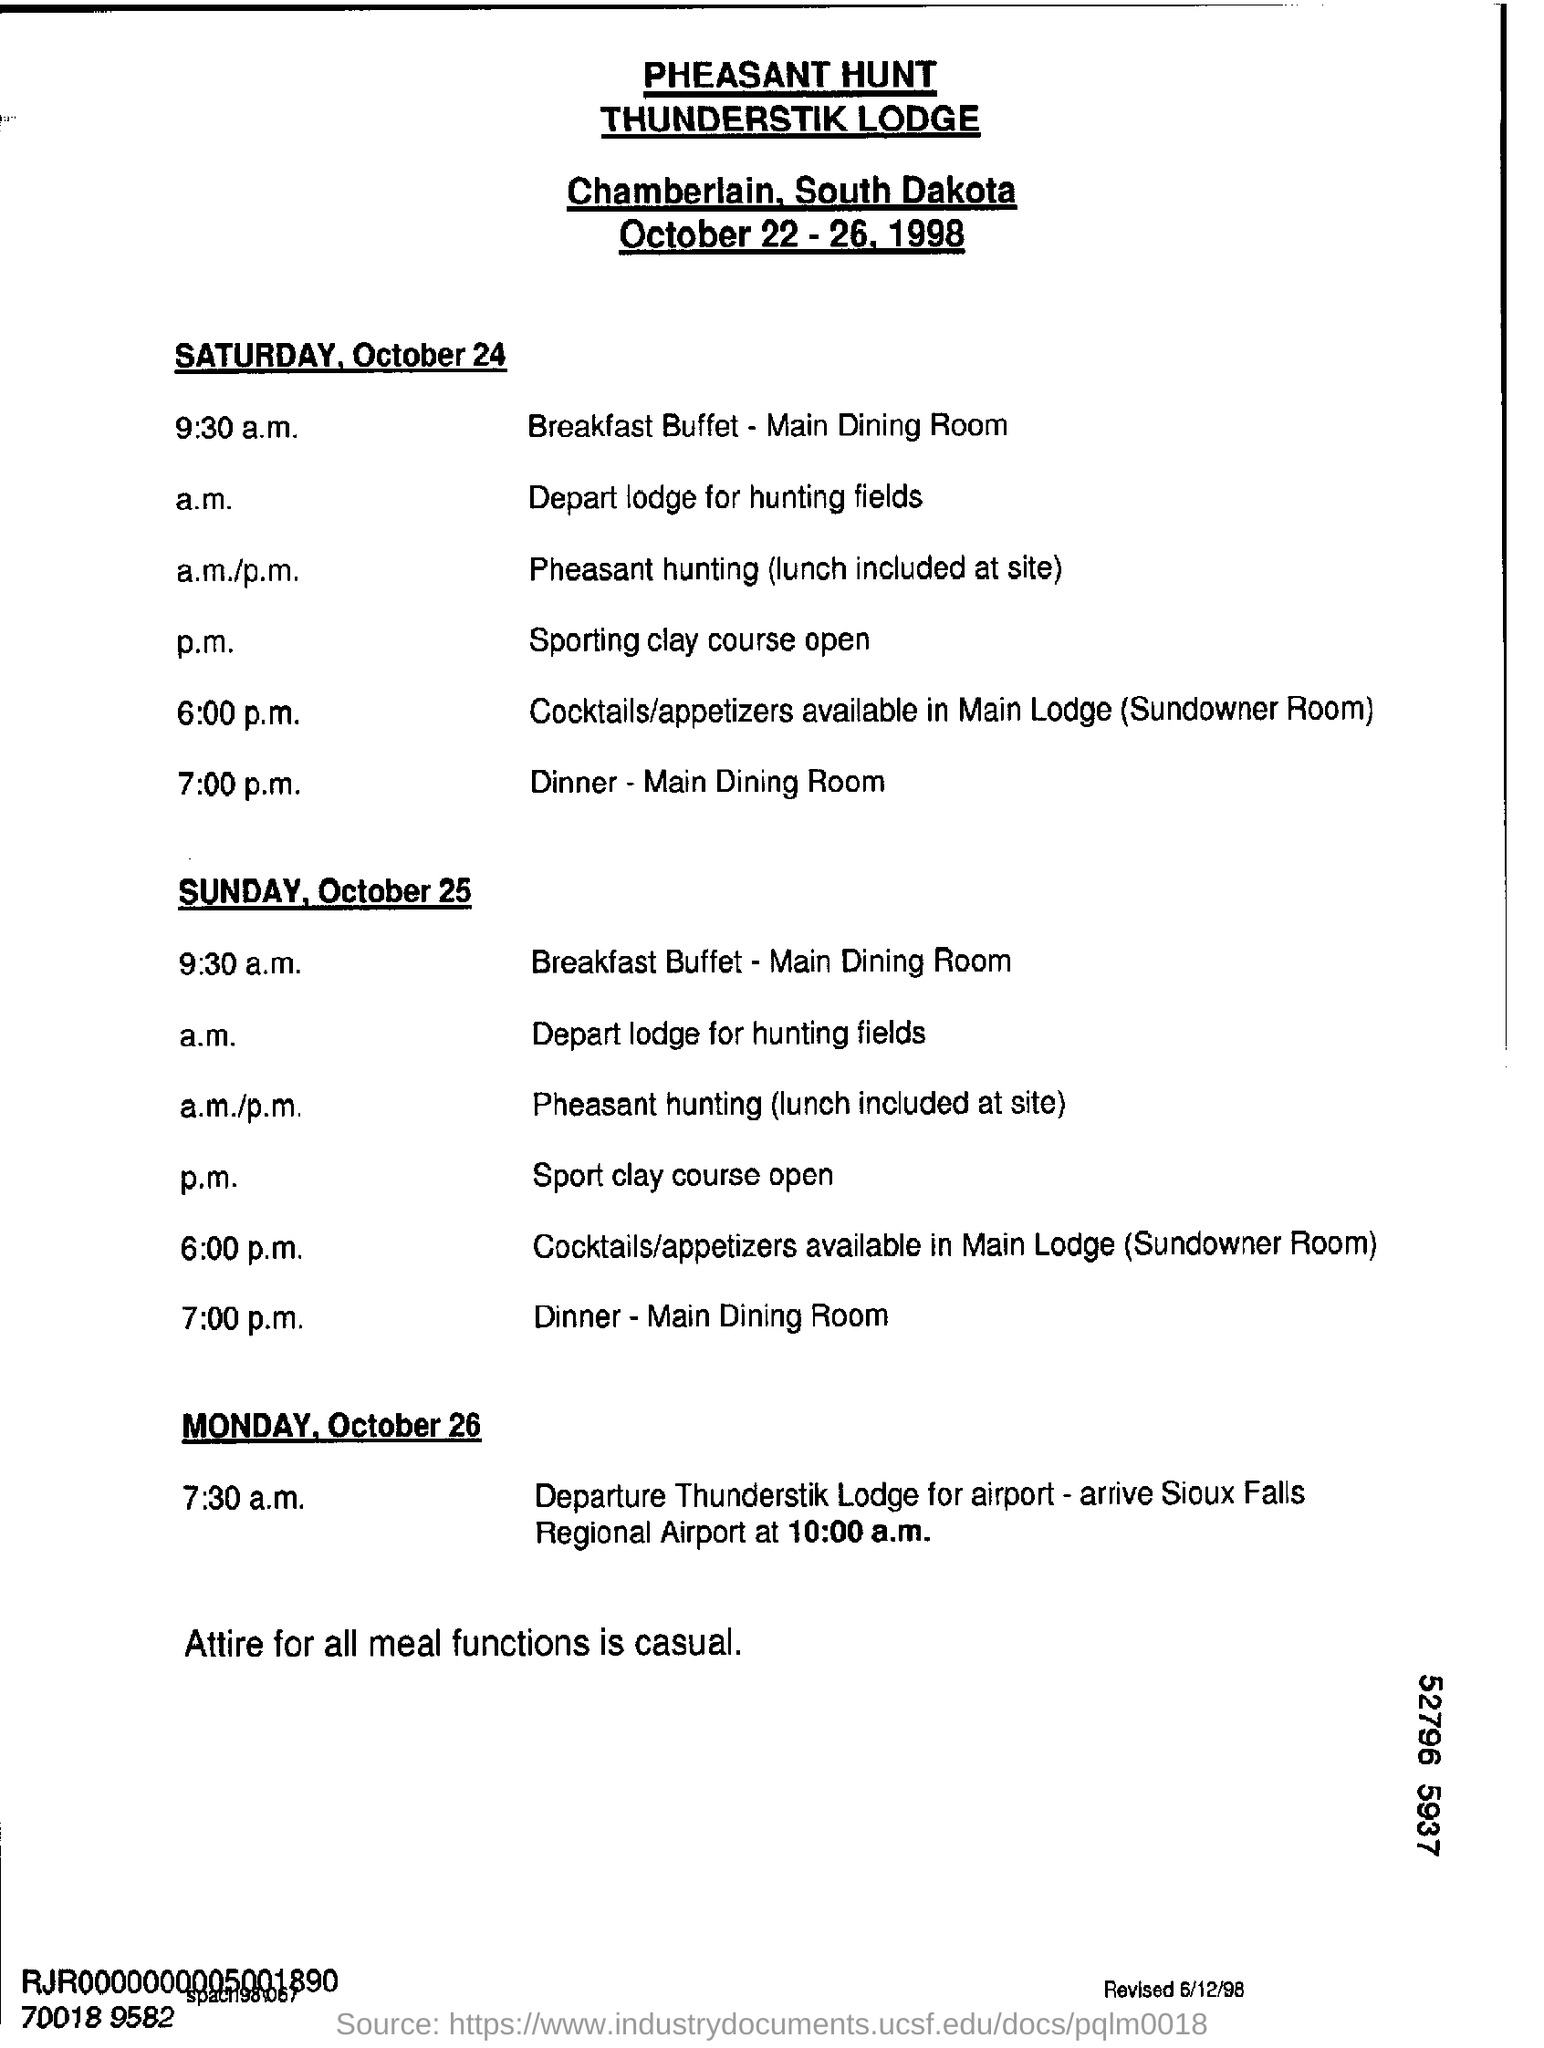Specify some key components in this picture. It is expected that the group will arrive at Sioux Regional Airport at 10:00 a.m. 